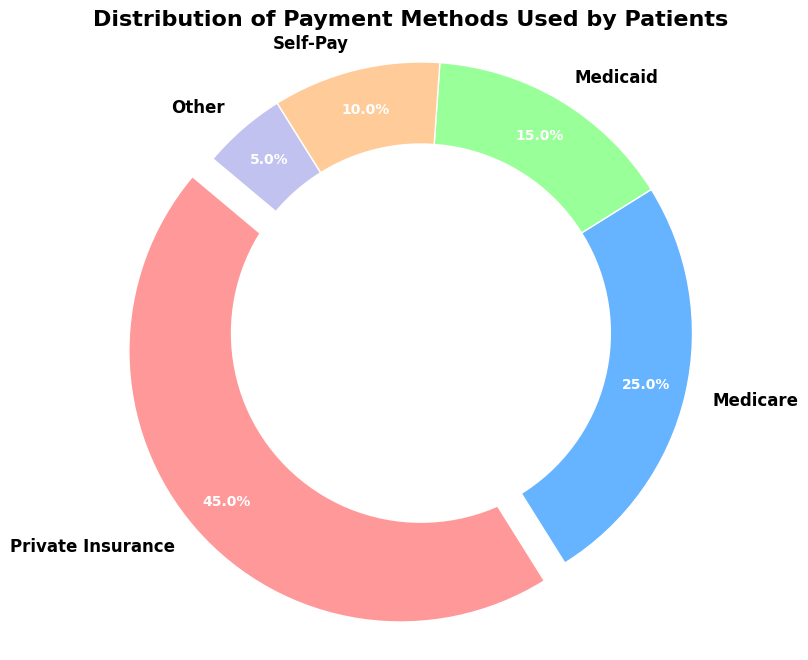what percentage of patients use self-pay as their payment method? The pie chart indicates each payment method's percentage. Look directly for "Self-Pay", which is labeled with its percentage.
Answer: 10% which payment method is the most popular among patients? The sector with the largest slice is slightly detached from the rest to highlight it. Check which label has this effect and the highest percentage.
Answer: Private Insurance how does the use of Medicaid compare to Medicare? Locate both segments labeled "Medicaid" and "Medicare" and compare their percentages. Medicaid is 15% while Medicare is 25%.
Answer: Medicare is 10% higher than Medicaid what is the combined percentage of patients using Medicaid and Medicare? Sum the percentages of Medicaid (15%) and Medicare (25%) to find the total. 15% + 25% = 40%.
Answer: 40% are there more patients using self-pay or other methods? Compare the percentage of Self-Pay (10%) and Other (5%).
Answer: More patients use Self-Pay what is the visual emphasis technique used to highlight the most popular payment method? Observe which visual modifications are applied to the largest slice, such as a slight separation from the center.
Answer: The most popular payment method is exploded slightly which segment has the least number of patients? Find the smallest slice in the chart.
Answer: Other how do the usage rates of public insurance options (Medicare and Medicaid) compare to private insurance? Combine the percentages of Medicare (25%) and Medicaid (15%) and compare the total (40%) to Private Insurance (45%). Private Insurance has a slight edge over the combined public insurance.
Answer: Private Insurance is 5% higher than combined public insurance what color represents Self-Pay patients in the pie chart? Identify the color associated with the label "Self-Pay" in the pie chart.
Answer: Light orange what is the total percentage of patients who don't use any form of public insurance (Medicare or Medicaid)? Subtract the combined public insurance percentage (40%) from 100% to get the percentage of patients using other payment methods. 100% - 40% = 60%.
Answer: 60% 